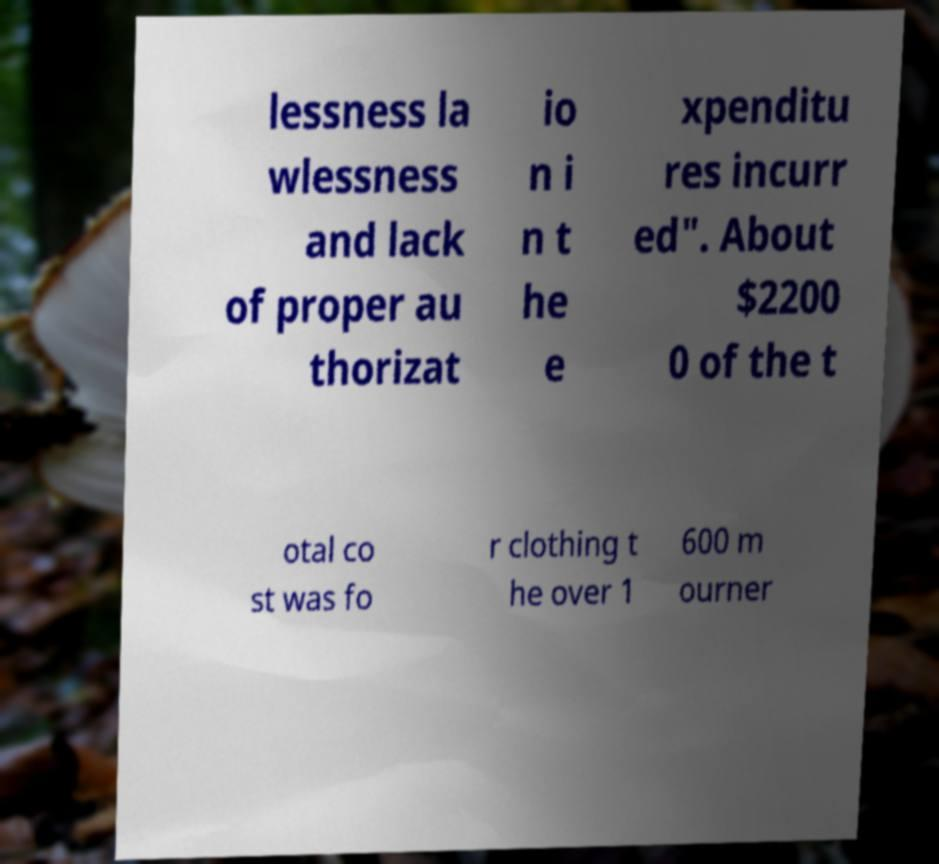For documentation purposes, I need the text within this image transcribed. Could you provide that? lessness la wlessness and lack of proper au thorizat io n i n t he e xpenditu res incurr ed". About $2200 0 of the t otal co st was fo r clothing t he over 1 600 m ourner 